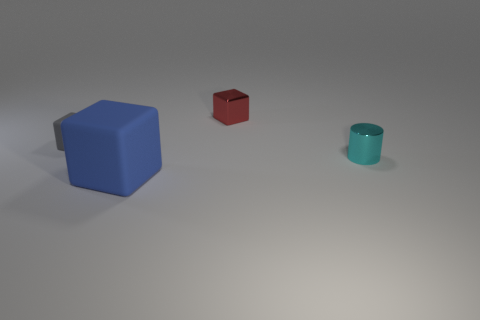What size is the other rubber object that is the same shape as the gray matte thing?
Your answer should be compact. Large. Is there any other thing that has the same color as the small metallic cylinder?
Ensure brevity in your answer.  No. What size is the object that is made of the same material as the blue block?
Offer a very short reply. Small. There is a tiny gray object; is it the same shape as the tiny shiny thing to the left of the tiny cyan metallic cylinder?
Your response must be concise. Yes. How big is the cyan cylinder?
Ensure brevity in your answer.  Small. Are there fewer shiny cylinders in front of the small matte block than big blue things?
Your answer should be very brief. No. What number of red shiny things have the same size as the cylinder?
Your response must be concise. 1. Is the color of the matte thing on the left side of the large thing the same as the thing that is in front of the small shiny cylinder?
Your response must be concise. No. What number of blocks are behind the small red cube?
Provide a succinct answer. 0. Is there a blue matte object of the same shape as the small red metal object?
Offer a very short reply. Yes. 